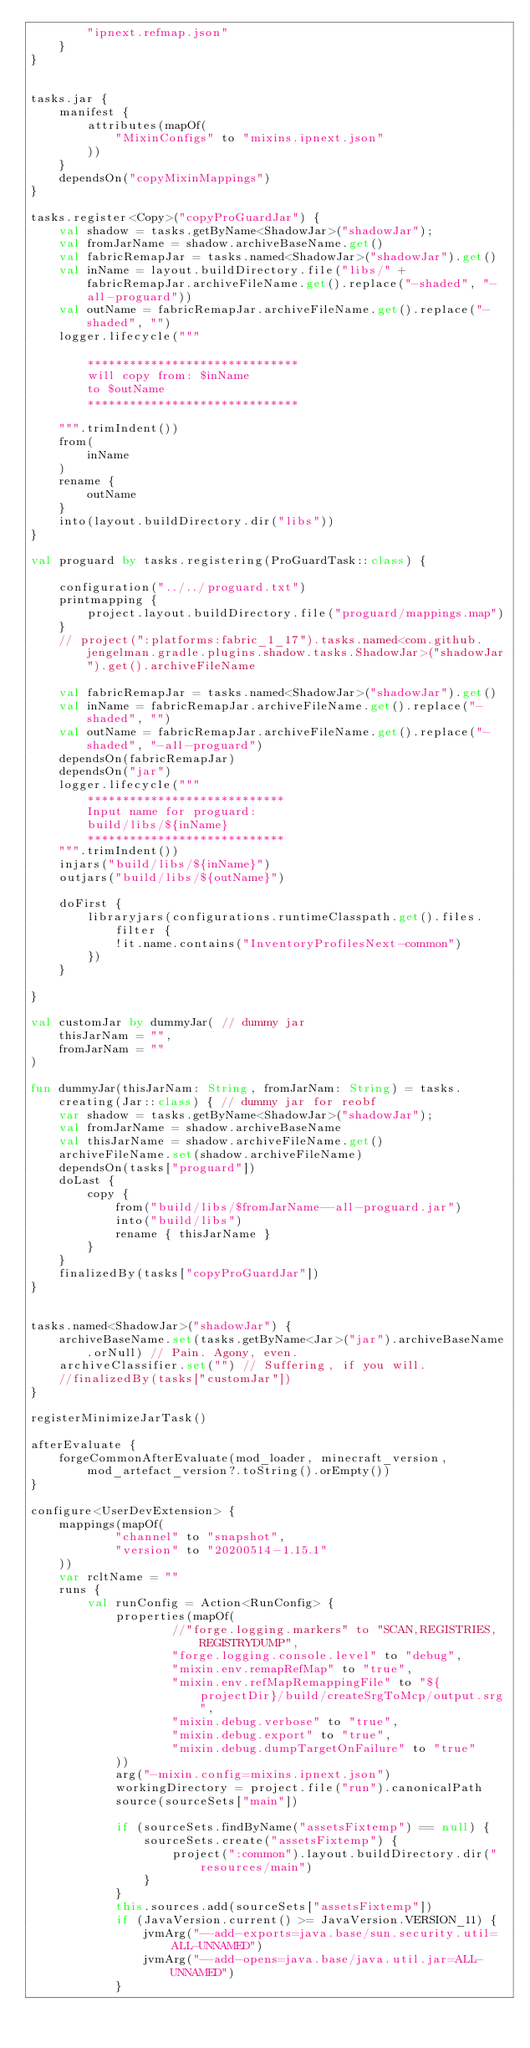Convert code to text. <code><loc_0><loc_0><loc_500><loc_500><_Kotlin_>        "ipnext.refmap.json"
    }
}


tasks.jar {
    manifest {
        attributes(mapOf(
            "MixinConfigs" to "mixins.ipnext.json"
        ))
    }
    dependsOn("copyMixinMappings")
}

tasks.register<Copy>("copyProGuardJar") {
    val shadow = tasks.getByName<ShadowJar>("shadowJar");
    val fromJarName = shadow.archiveBaseName.get()
    val fabricRemapJar = tasks.named<ShadowJar>("shadowJar").get()
    val inName = layout.buildDirectory.file("libs/" + fabricRemapJar.archiveFileName.get().replace("-shaded", "-all-proguard"))
    val outName = fabricRemapJar.archiveFileName.get().replace("-shaded", "")
    logger.lifecycle("""
        
        ******************************
        will copy from: $inName
        to $outName
        ******************************
        
    """.trimIndent())
    from(
        inName
    )
    rename {
        outName
    }
    into(layout.buildDirectory.dir("libs"))
}

val proguard by tasks.registering(ProGuardTask::class) {

    configuration("../../proguard.txt")
    printmapping {
        project.layout.buildDirectory.file("proguard/mappings.map")
    }
    // project(":platforms:fabric_1_17").tasks.named<com.github.jengelman.gradle.plugins.shadow.tasks.ShadowJar>("shadowJar").get().archiveFileName

    val fabricRemapJar = tasks.named<ShadowJar>("shadowJar").get()
    val inName = fabricRemapJar.archiveFileName.get().replace("-shaded", "")
    val outName = fabricRemapJar.archiveFileName.get().replace("-shaded", "-all-proguard")
    dependsOn(fabricRemapJar)
    dependsOn("jar")
    logger.lifecycle(""" 
        ****************************
        Input name for proguard:
        build/libs/${inName}
        ****************************
    """.trimIndent())
    injars("build/libs/${inName}")
    outjars("build/libs/${outName}")

    doFirst {
        libraryjars(configurations.runtimeClasspath.get().files.filter {
            !it.name.contains("InventoryProfilesNext-common")
        })
    }

}

val customJar by dummyJar( // dummy jar
    thisJarNam = "",
    fromJarNam = ""
)

fun dummyJar(thisJarNam: String, fromJarNam: String) = tasks.creating(Jar::class) { // dummy jar for reobf
    var shadow = tasks.getByName<ShadowJar>("shadowJar");
    val fromJarName = shadow.archiveBaseName
    val thisJarName = shadow.archiveFileName.get()
    archiveFileName.set(shadow.archiveFileName)
    dependsOn(tasks["proguard"])
    doLast {
        copy {
            from("build/libs/$fromJarName--all-proguard.jar")
            into("build/libs")
            rename { thisJarName }
        }
    }
    finalizedBy(tasks["copyProGuardJar"])
}


tasks.named<ShadowJar>("shadowJar") {
    archiveBaseName.set(tasks.getByName<Jar>("jar").archiveBaseName.orNull) // Pain. Agony, even.
    archiveClassifier.set("") // Suffering, if you will.
    //finalizedBy(tasks["customJar"])
}

registerMinimizeJarTask()

afterEvaluate {
    forgeCommonAfterEvaluate(mod_loader, minecraft_version, mod_artefact_version?.toString().orEmpty())
}

configure<UserDevExtension> {
    mappings(mapOf(
            "channel" to "snapshot",
            "version" to "20200514-1.15.1"
    ))
    var rcltName = ""
    runs {
        val runConfig = Action<RunConfig> {
            properties(mapOf(
                    //"forge.logging.markers" to "SCAN,REGISTRIES,REGISTRYDUMP",
                    "forge.logging.console.level" to "debug",
                    "mixin.env.remapRefMap" to "true",
                    "mixin.env.refMapRemappingFile" to "${projectDir}/build/createSrgToMcp/output.srg",
                    "mixin.debug.verbose" to "true",
                    "mixin.debug.export" to "true",
                    "mixin.debug.dumpTargetOnFailure" to "true"
            ))
            arg("-mixin.config=mixins.ipnext.json")
            workingDirectory = project.file("run").canonicalPath
            source(sourceSets["main"])

            if (sourceSets.findByName("assetsFixtemp") == null) {
                sourceSets.create("assetsFixtemp") {
                    project(":common").layout.buildDirectory.dir("resources/main")
                }
            }
            this.sources.add(sourceSets["assetsFixtemp"])
            if (JavaVersion.current() >= JavaVersion.VERSION_11) {
                jvmArg("--add-exports=java.base/sun.security.util=ALL-UNNAMED")
                jvmArg("--add-opens=java.base/java.util.jar=ALL-UNNAMED")
            }</code> 